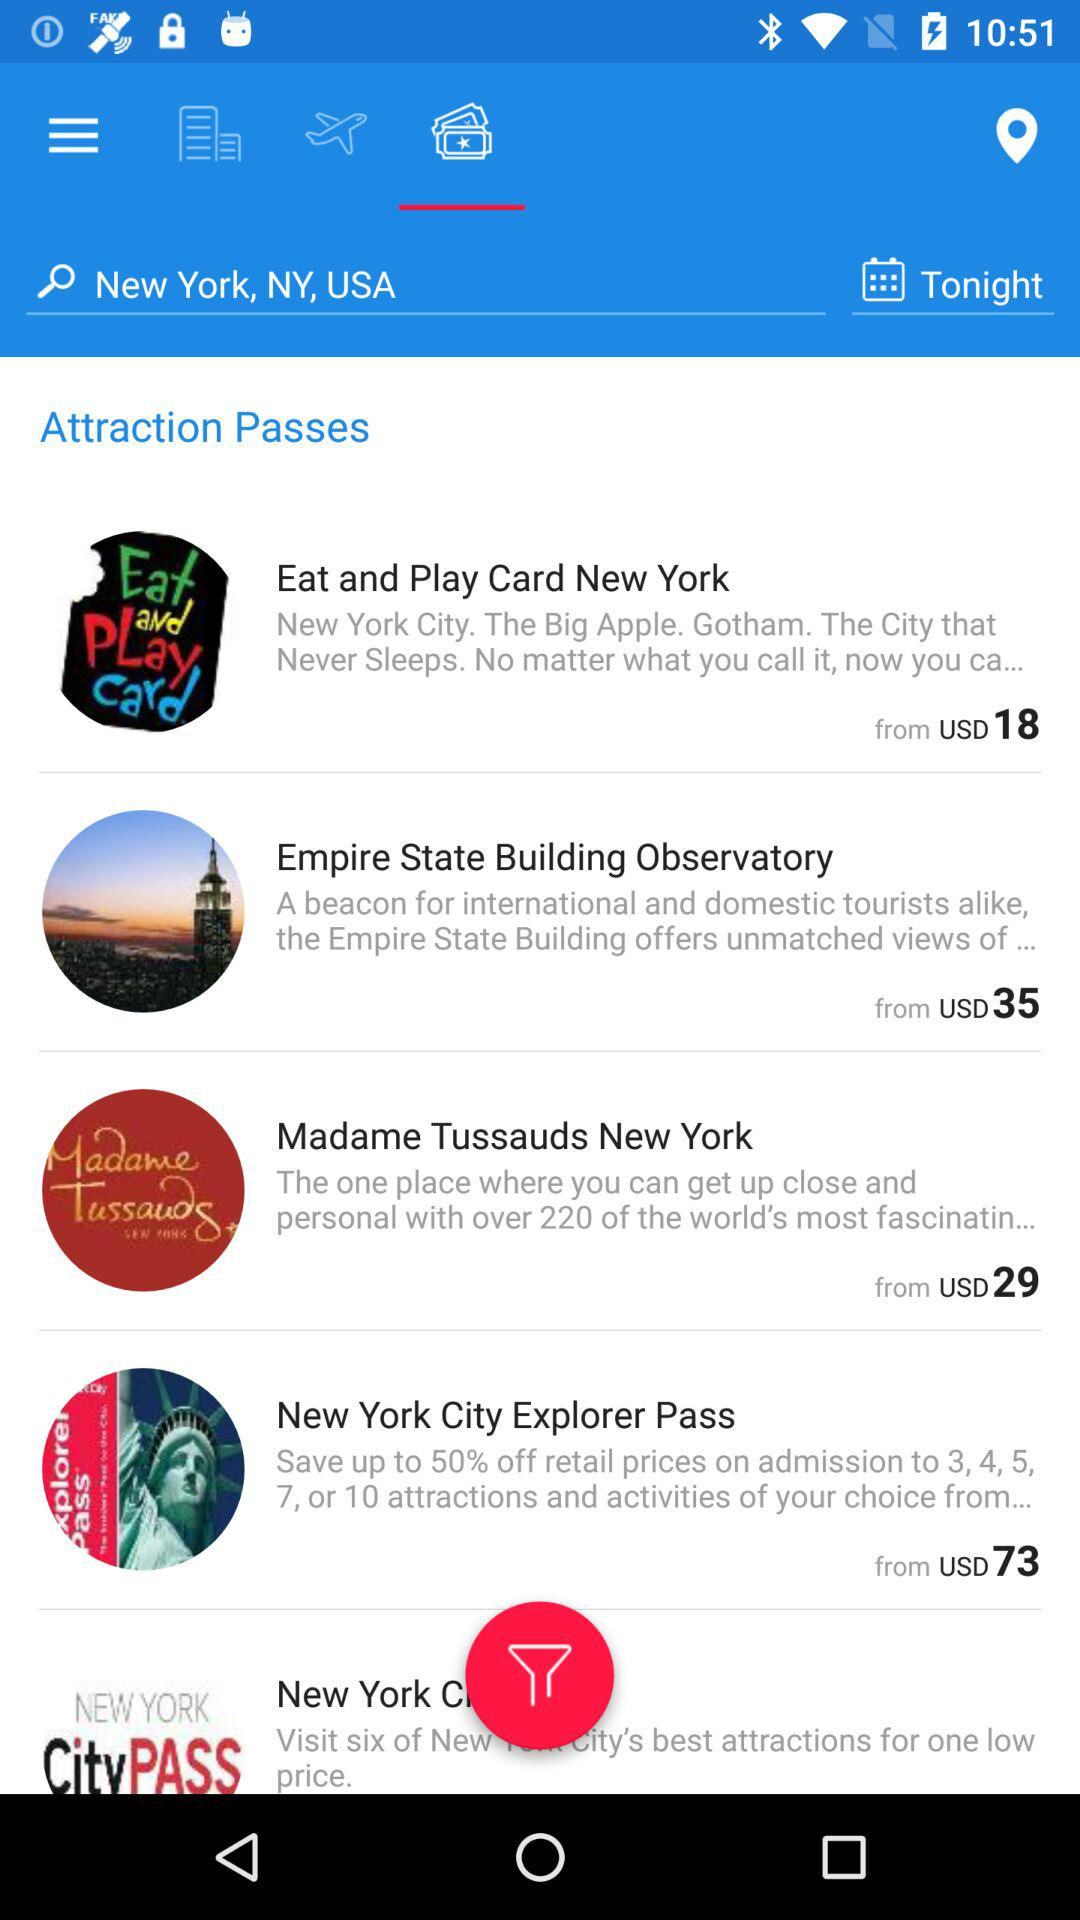How much is the pass amount for the "Empire State Building Observatory"? The pass amount for the "Empire State Building Observatory" starts at 35 USD. 